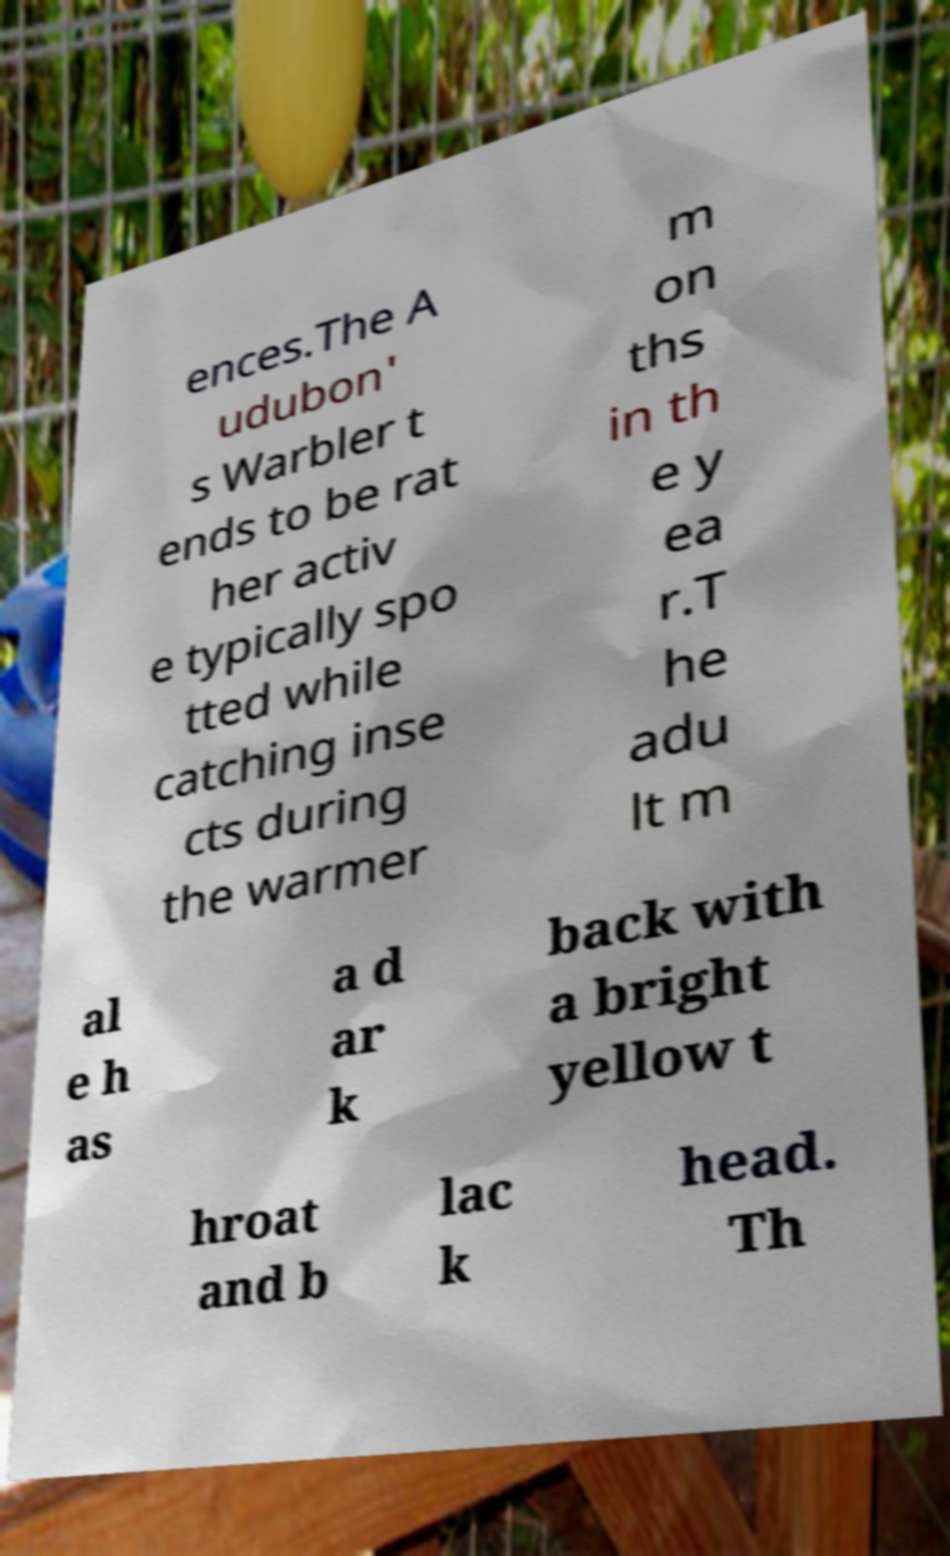Could you assist in decoding the text presented in this image and type it out clearly? ences.The A udubon' s Warbler t ends to be rat her activ e typically spo tted while catching inse cts during the warmer m on ths in th e y ea r.T he adu lt m al e h as a d ar k back with a bright yellow t hroat and b lac k head. Th 